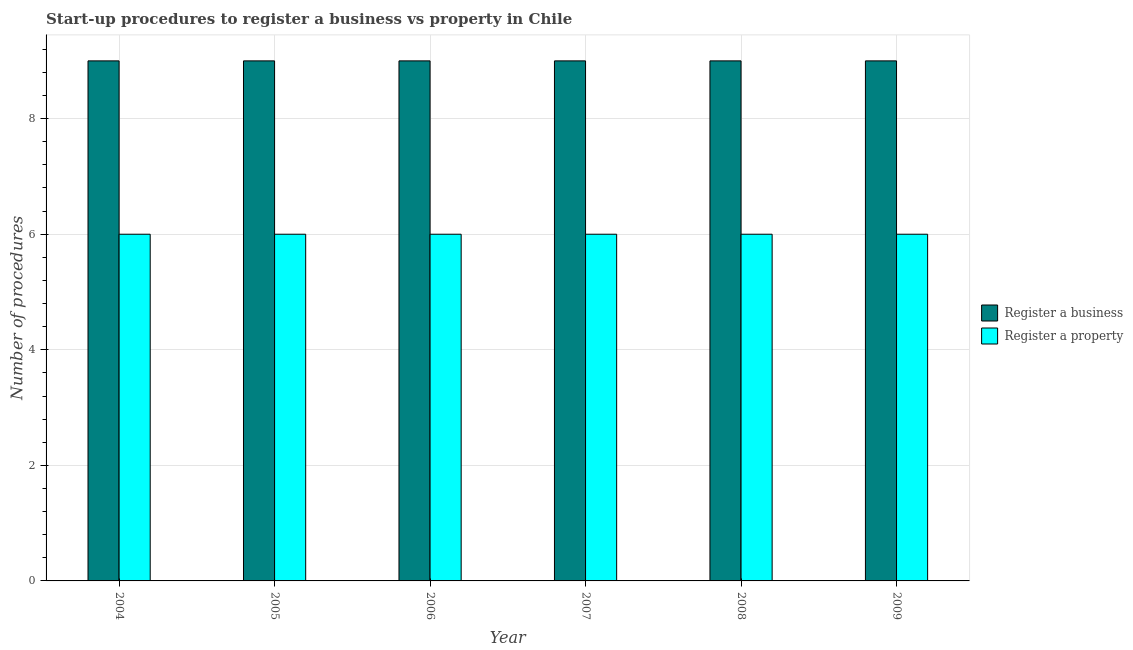How many different coloured bars are there?
Ensure brevity in your answer.  2. How many groups of bars are there?
Give a very brief answer. 6. In how many cases, is the number of bars for a given year not equal to the number of legend labels?
Offer a very short reply. 0. What is the number of procedures to register a business in 2004?
Give a very brief answer. 9. Across all years, what is the maximum number of procedures to register a business?
Offer a very short reply. 9. Across all years, what is the minimum number of procedures to register a business?
Make the answer very short. 9. What is the total number of procedures to register a property in the graph?
Provide a succinct answer. 36. What is the difference between the number of procedures to register a property in 2005 and that in 2008?
Offer a terse response. 0. What is the difference between the number of procedures to register a property in 2007 and the number of procedures to register a business in 2004?
Offer a very short reply. 0. Is the number of procedures to register a business in 2006 less than that in 2008?
Your answer should be compact. No. Is the difference between the number of procedures to register a business in 2004 and 2009 greater than the difference between the number of procedures to register a property in 2004 and 2009?
Your answer should be compact. No. What is the difference between the highest and the lowest number of procedures to register a business?
Your answer should be very brief. 0. What does the 1st bar from the left in 2005 represents?
Provide a succinct answer. Register a business. What does the 2nd bar from the right in 2008 represents?
Keep it short and to the point. Register a business. What is the difference between two consecutive major ticks on the Y-axis?
Ensure brevity in your answer.  2. Does the graph contain any zero values?
Your response must be concise. No. How many legend labels are there?
Your response must be concise. 2. What is the title of the graph?
Your answer should be compact. Start-up procedures to register a business vs property in Chile. What is the label or title of the X-axis?
Your answer should be very brief. Year. What is the label or title of the Y-axis?
Your answer should be very brief. Number of procedures. What is the Number of procedures in Register a property in 2004?
Offer a very short reply. 6. What is the Number of procedures of Register a business in 2005?
Your answer should be very brief. 9. What is the Number of procedures of Register a property in 2005?
Offer a terse response. 6. What is the Number of procedures of Register a property in 2006?
Make the answer very short. 6. What is the Number of procedures in Register a business in 2008?
Offer a terse response. 9. What is the Number of procedures in Register a property in 2009?
Ensure brevity in your answer.  6. Across all years, what is the minimum Number of procedures in Register a business?
Ensure brevity in your answer.  9. Across all years, what is the minimum Number of procedures of Register a property?
Your answer should be very brief. 6. What is the total Number of procedures of Register a business in the graph?
Your response must be concise. 54. What is the total Number of procedures in Register a property in the graph?
Your answer should be very brief. 36. What is the difference between the Number of procedures of Register a property in 2004 and that in 2005?
Your answer should be compact. 0. What is the difference between the Number of procedures in Register a business in 2004 and that in 2006?
Provide a succinct answer. 0. What is the difference between the Number of procedures in Register a business in 2004 and that in 2007?
Offer a terse response. 0. What is the difference between the Number of procedures of Register a property in 2004 and that in 2008?
Make the answer very short. 0. What is the difference between the Number of procedures in Register a business in 2004 and that in 2009?
Ensure brevity in your answer.  0. What is the difference between the Number of procedures of Register a business in 2005 and that in 2006?
Make the answer very short. 0. What is the difference between the Number of procedures in Register a business in 2005 and that in 2007?
Ensure brevity in your answer.  0. What is the difference between the Number of procedures in Register a property in 2005 and that in 2007?
Your answer should be compact. 0. What is the difference between the Number of procedures of Register a business in 2005 and that in 2008?
Your response must be concise. 0. What is the difference between the Number of procedures in Register a property in 2005 and that in 2008?
Your answer should be very brief. 0. What is the difference between the Number of procedures in Register a property in 2005 and that in 2009?
Your answer should be compact. 0. What is the difference between the Number of procedures in Register a business in 2006 and that in 2007?
Ensure brevity in your answer.  0. What is the difference between the Number of procedures in Register a property in 2006 and that in 2007?
Give a very brief answer. 0. What is the difference between the Number of procedures of Register a business in 2006 and that in 2008?
Offer a terse response. 0. What is the difference between the Number of procedures of Register a property in 2006 and that in 2008?
Your answer should be very brief. 0. What is the difference between the Number of procedures in Register a business in 2006 and that in 2009?
Keep it short and to the point. 0. What is the difference between the Number of procedures in Register a property in 2006 and that in 2009?
Provide a short and direct response. 0. What is the difference between the Number of procedures in Register a business in 2007 and that in 2008?
Make the answer very short. 0. What is the difference between the Number of procedures of Register a property in 2007 and that in 2009?
Your answer should be very brief. 0. What is the difference between the Number of procedures in Register a business in 2008 and that in 2009?
Give a very brief answer. 0. What is the difference between the Number of procedures in Register a property in 2008 and that in 2009?
Provide a short and direct response. 0. What is the difference between the Number of procedures in Register a business in 2004 and the Number of procedures in Register a property in 2006?
Give a very brief answer. 3. What is the difference between the Number of procedures of Register a business in 2004 and the Number of procedures of Register a property in 2009?
Keep it short and to the point. 3. What is the difference between the Number of procedures in Register a business in 2005 and the Number of procedures in Register a property in 2006?
Offer a terse response. 3. What is the difference between the Number of procedures of Register a business in 2005 and the Number of procedures of Register a property in 2007?
Your answer should be very brief. 3. What is the difference between the Number of procedures in Register a business in 2005 and the Number of procedures in Register a property in 2009?
Make the answer very short. 3. What is the difference between the Number of procedures of Register a business in 2006 and the Number of procedures of Register a property in 2008?
Provide a succinct answer. 3. What is the difference between the Number of procedures in Register a business in 2006 and the Number of procedures in Register a property in 2009?
Offer a terse response. 3. What is the difference between the Number of procedures in Register a business in 2008 and the Number of procedures in Register a property in 2009?
Your response must be concise. 3. What is the average Number of procedures of Register a property per year?
Offer a very short reply. 6. In the year 2005, what is the difference between the Number of procedures of Register a business and Number of procedures of Register a property?
Provide a short and direct response. 3. In the year 2006, what is the difference between the Number of procedures of Register a business and Number of procedures of Register a property?
Ensure brevity in your answer.  3. In the year 2008, what is the difference between the Number of procedures in Register a business and Number of procedures in Register a property?
Ensure brevity in your answer.  3. What is the ratio of the Number of procedures in Register a business in 2004 to that in 2005?
Ensure brevity in your answer.  1. What is the ratio of the Number of procedures of Register a property in 2004 to that in 2006?
Ensure brevity in your answer.  1. What is the ratio of the Number of procedures in Register a business in 2005 to that in 2006?
Provide a short and direct response. 1. What is the ratio of the Number of procedures of Register a property in 2005 to that in 2006?
Your answer should be very brief. 1. What is the ratio of the Number of procedures of Register a business in 2005 to that in 2008?
Keep it short and to the point. 1. What is the ratio of the Number of procedures in Register a business in 2006 to that in 2007?
Give a very brief answer. 1. What is the ratio of the Number of procedures of Register a business in 2006 to that in 2008?
Your answer should be compact. 1. What is the ratio of the Number of procedures of Register a property in 2006 to that in 2008?
Provide a short and direct response. 1. What is the ratio of the Number of procedures in Register a business in 2006 to that in 2009?
Provide a short and direct response. 1. What is the ratio of the Number of procedures in Register a property in 2006 to that in 2009?
Provide a succinct answer. 1. What is the ratio of the Number of procedures of Register a business in 2007 to that in 2008?
Keep it short and to the point. 1. What is the ratio of the Number of procedures in Register a property in 2007 to that in 2008?
Ensure brevity in your answer.  1. What is the ratio of the Number of procedures of Register a property in 2007 to that in 2009?
Offer a terse response. 1. What is the difference between the highest and the second highest Number of procedures of Register a business?
Keep it short and to the point. 0. What is the difference between the highest and the second highest Number of procedures in Register a property?
Provide a succinct answer. 0. 